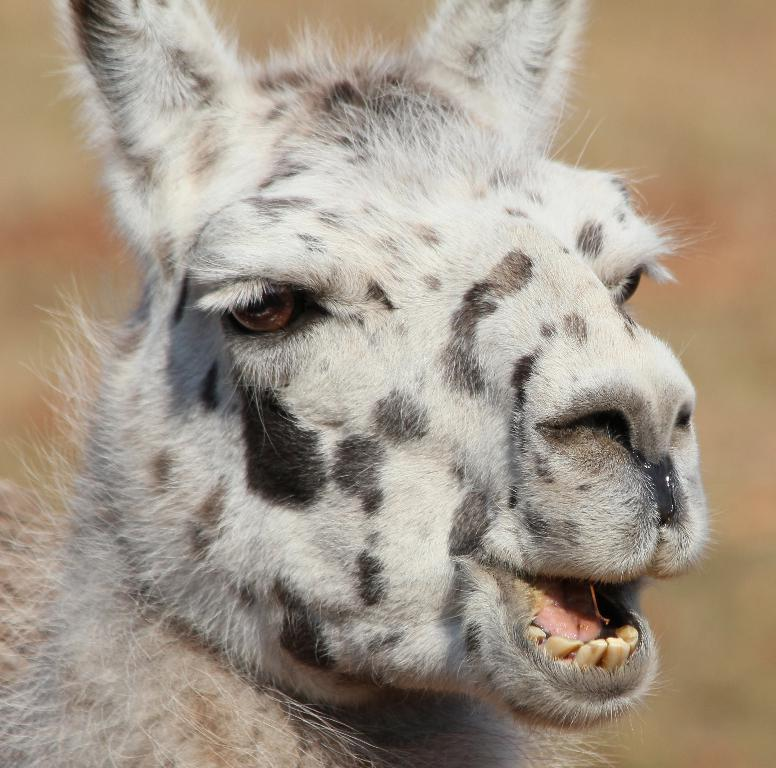What type of creature is present in the image? There is an animal in the image. Can you describe the background of the image? The background of the image is blurred. How many eggs are used in the glue depicted in the image? There is no glue or eggs present in the image; it features an animal with a blurred background. 